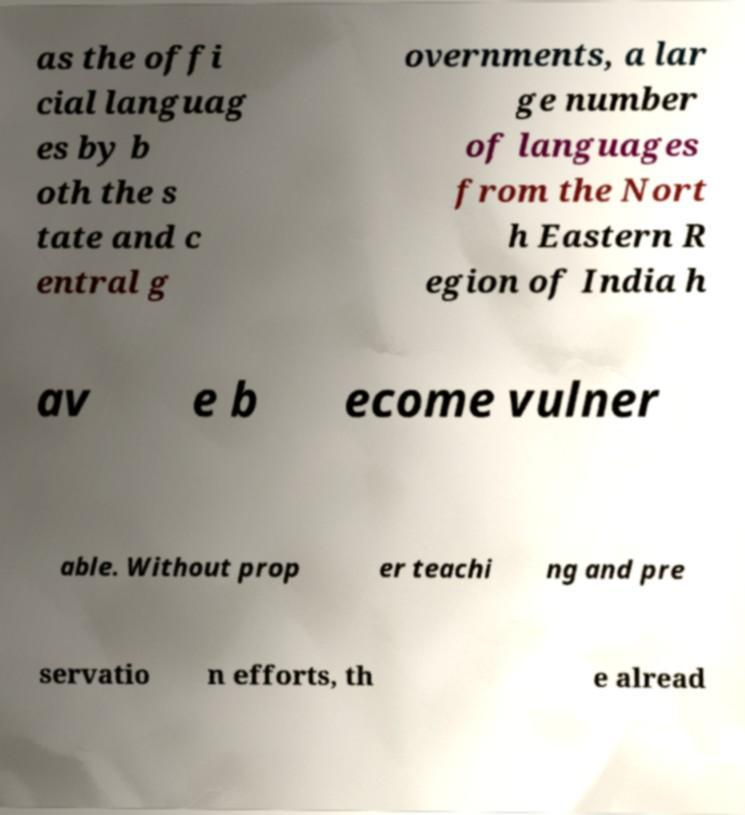There's text embedded in this image that I need extracted. Can you transcribe it verbatim? as the offi cial languag es by b oth the s tate and c entral g overnments, a lar ge number of languages from the Nort h Eastern R egion of India h av e b ecome vulner able. Without prop er teachi ng and pre servatio n efforts, th e alread 